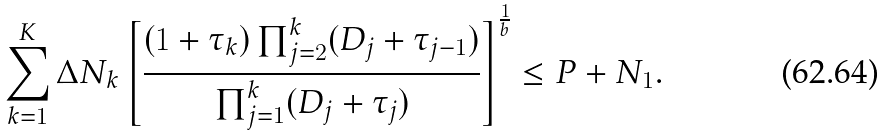Convert formula to latex. <formula><loc_0><loc_0><loc_500><loc_500>\sum _ { k = 1 } ^ { K } \Delta N _ { k } \left [ \frac { ( 1 + \tau _ { k } ) \prod _ { j = 2 } ^ { k } ( D _ { j } + \tau _ { j - 1 } ) } { \prod _ { j = 1 } ^ { k } ( D _ { j } + \tau _ { j } ) } \right ] ^ { \frac { 1 } { b } } \leq P + N _ { 1 } .</formula> 